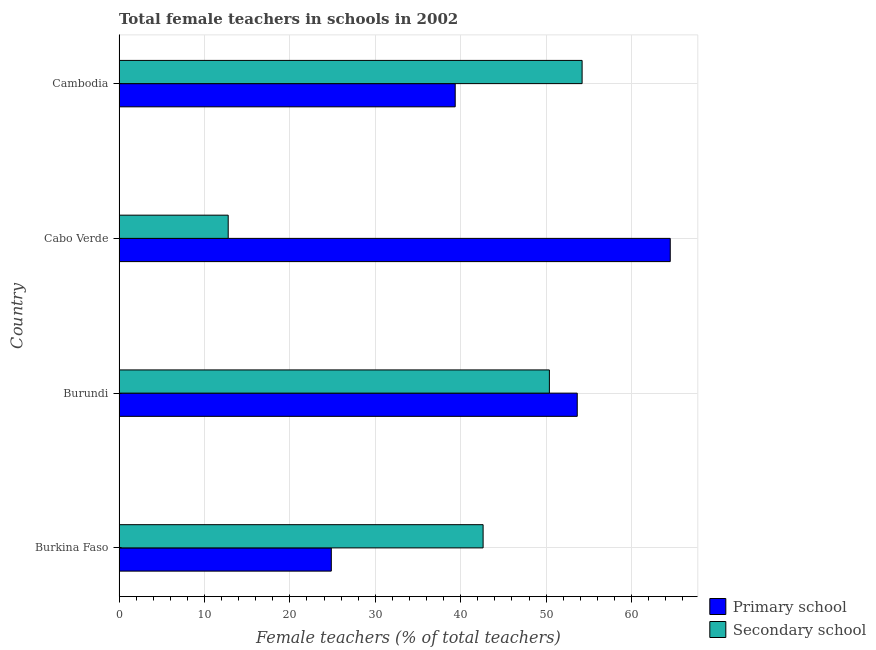How many different coloured bars are there?
Keep it short and to the point. 2. How many groups of bars are there?
Make the answer very short. 4. Are the number of bars per tick equal to the number of legend labels?
Provide a succinct answer. Yes. Are the number of bars on each tick of the Y-axis equal?
Provide a succinct answer. Yes. What is the label of the 3rd group of bars from the top?
Ensure brevity in your answer.  Burundi. What is the percentage of female teachers in primary schools in Cabo Verde?
Your response must be concise. 64.53. Across all countries, what is the maximum percentage of female teachers in primary schools?
Your answer should be compact. 64.53. Across all countries, what is the minimum percentage of female teachers in secondary schools?
Make the answer very short. 12.78. In which country was the percentage of female teachers in secondary schools maximum?
Keep it short and to the point. Cambodia. In which country was the percentage of female teachers in primary schools minimum?
Your response must be concise. Burkina Faso. What is the total percentage of female teachers in primary schools in the graph?
Your answer should be compact. 182.38. What is the difference between the percentage of female teachers in primary schools in Burkina Faso and that in Burundi?
Keep it short and to the point. -28.79. What is the difference between the percentage of female teachers in primary schools in Burundi and the percentage of female teachers in secondary schools in Burkina Faso?
Your response must be concise. 11.02. What is the average percentage of female teachers in secondary schools per country?
Make the answer very short. 40. What is the difference between the percentage of female teachers in primary schools and percentage of female teachers in secondary schools in Cabo Verde?
Make the answer very short. 51.75. In how many countries, is the percentage of female teachers in secondary schools greater than 62 %?
Offer a very short reply. 0. What is the ratio of the percentage of female teachers in primary schools in Burkina Faso to that in Cambodia?
Offer a terse response. 0.63. Is the percentage of female teachers in primary schools in Burkina Faso less than that in Cambodia?
Ensure brevity in your answer.  Yes. Is the difference between the percentage of female teachers in primary schools in Burkina Faso and Cambodia greater than the difference between the percentage of female teachers in secondary schools in Burkina Faso and Cambodia?
Give a very brief answer. No. What is the difference between the highest and the second highest percentage of female teachers in secondary schools?
Give a very brief answer. 3.83. What is the difference between the highest and the lowest percentage of female teachers in primary schools?
Your answer should be very brief. 39.68. What does the 1st bar from the top in Cambodia represents?
Your answer should be very brief. Secondary school. What does the 1st bar from the bottom in Burundi represents?
Keep it short and to the point. Primary school. How many bars are there?
Your answer should be compact. 8. Are all the bars in the graph horizontal?
Make the answer very short. Yes. How many legend labels are there?
Ensure brevity in your answer.  2. What is the title of the graph?
Your answer should be very brief. Total female teachers in schools in 2002. What is the label or title of the X-axis?
Provide a succinct answer. Female teachers (% of total teachers). What is the Female teachers (% of total teachers) of Primary school in Burkina Faso?
Your answer should be compact. 24.85. What is the Female teachers (% of total teachers) of Secondary school in Burkina Faso?
Give a very brief answer. 42.62. What is the Female teachers (% of total teachers) in Primary school in Burundi?
Give a very brief answer. 53.64. What is the Female teachers (% of total teachers) in Secondary school in Burundi?
Provide a short and direct response. 50.38. What is the Female teachers (% of total teachers) of Primary school in Cabo Verde?
Keep it short and to the point. 64.53. What is the Female teachers (% of total teachers) in Secondary school in Cabo Verde?
Your answer should be compact. 12.78. What is the Female teachers (% of total teachers) of Primary school in Cambodia?
Give a very brief answer. 39.36. What is the Female teachers (% of total teachers) in Secondary school in Cambodia?
Offer a terse response. 54.21. Across all countries, what is the maximum Female teachers (% of total teachers) of Primary school?
Your response must be concise. 64.53. Across all countries, what is the maximum Female teachers (% of total teachers) of Secondary school?
Make the answer very short. 54.21. Across all countries, what is the minimum Female teachers (% of total teachers) of Primary school?
Make the answer very short. 24.85. Across all countries, what is the minimum Female teachers (% of total teachers) of Secondary school?
Keep it short and to the point. 12.78. What is the total Female teachers (% of total teachers) of Primary school in the graph?
Offer a terse response. 182.38. What is the total Female teachers (% of total teachers) of Secondary school in the graph?
Your answer should be very brief. 159.99. What is the difference between the Female teachers (% of total teachers) in Primary school in Burkina Faso and that in Burundi?
Keep it short and to the point. -28.79. What is the difference between the Female teachers (% of total teachers) of Secondary school in Burkina Faso and that in Burundi?
Offer a terse response. -7.76. What is the difference between the Female teachers (% of total teachers) in Primary school in Burkina Faso and that in Cabo Verde?
Your answer should be compact. -39.68. What is the difference between the Female teachers (% of total teachers) of Secondary school in Burkina Faso and that in Cabo Verde?
Offer a very short reply. 29.84. What is the difference between the Female teachers (% of total teachers) in Primary school in Burkina Faso and that in Cambodia?
Your answer should be compact. -14.51. What is the difference between the Female teachers (% of total teachers) of Secondary school in Burkina Faso and that in Cambodia?
Make the answer very short. -11.59. What is the difference between the Female teachers (% of total teachers) of Primary school in Burundi and that in Cabo Verde?
Ensure brevity in your answer.  -10.89. What is the difference between the Female teachers (% of total teachers) in Secondary school in Burundi and that in Cabo Verde?
Give a very brief answer. 37.6. What is the difference between the Female teachers (% of total teachers) of Primary school in Burundi and that in Cambodia?
Keep it short and to the point. 14.29. What is the difference between the Female teachers (% of total teachers) in Secondary school in Burundi and that in Cambodia?
Your response must be concise. -3.83. What is the difference between the Female teachers (% of total teachers) in Primary school in Cabo Verde and that in Cambodia?
Your response must be concise. 25.18. What is the difference between the Female teachers (% of total teachers) in Secondary school in Cabo Verde and that in Cambodia?
Keep it short and to the point. -41.43. What is the difference between the Female teachers (% of total teachers) of Primary school in Burkina Faso and the Female teachers (% of total teachers) of Secondary school in Burundi?
Your answer should be very brief. -25.53. What is the difference between the Female teachers (% of total teachers) in Primary school in Burkina Faso and the Female teachers (% of total teachers) in Secondary school in Cabo Verde?
Your response must be concise. 12.07. What is the difference between the Female teachers (% of total teachers) in Primary school in Burkina Faso and the Female teachers (% of total teachers) in Secondary school in Cambodia?
Your answer should be very brief. -29.36. What is the difference between the Female teachers (% of total teachers) in Primary school in Burundi and the Female teachers (% of total teachers) in Secondary school in Cabo Verde?
Keep it short and to the point. 40.86. What is the difference between the Female teachers (% of total teachers) in Primary school in Burundi and the Female teachers (% of total teachers) in Secondary school in Cambodia?
Make the answer very short. -0.57. What is the difference between the Female teachers (% of total teachers) in Primary school in Cabo Verde and the Female teachers (% of total teachers) in Secondary school in Cambodia?
Keep it short and to the point. 10.32. What is the average Female teachers (% of total teachers) in Primary school per country?
Your answer should be very brief. 45.59. What is the average Female teachers (% of total teachers) of Secondary school per country?
Keep it short and to the point. 40. What is the difference between the Female teachers (% of total teachers) of Primary school and Female teachers (% of total teachers) of Secondary school in Burkina Faso?
Keep it short and to the point. -17.77. What is the difference between the Female teachers (% of total teachers) in Primary school and Female teachers (% of total teachers) in Secondary school in Burundi?
Make the answer very short. 3.26. What is the difference between the Female teachers (% of total teachers) in Primary school and Female teachers (% of total teachers) in Secondary school in Cabo Verde?
Your answer should be very brief. 51.75. What is the difference between the Female teachers (% of total teachers) in Primary school and Female teachers (% of total teachers) in Secondary school in Cambodia?
Keep it short and to the point. -14.86. What is the ratio of the Female teachers (% of total teachers) of Primary school in Burkina Faso to that in Burundi?
Your answer should be compact. 0.46. What is the ratio of the Female teachers (% of total teachers) of Secondary school in Burkina Faso to that in Burundi?
Offer a very short reply. 0.85. What is the ratio of the Female teachers (% of total teachers) in Primary school in Burkina Faso to that in Cabo Verde?
Keep it short and to the point. 0.39. What is the ratio of the Female teachers (% of total teachers) in Secondary school in Burkina Faso to that in Cabo Verde?
Provide a succinct answer. 3.34. What is the ratio of the Female teachers (% of total teachers) of Primary school in Burkina Faso to that in Cambodia?
Offer a very short reply. 0.63. What is the ratio of the Female teachers (% of total teachers) of Secondary school in Burkina Faso to that in Cambodia?
Offer a very short reply. 0.79. What is the ratio of the Female teachers (% of total teachers) of Primary school in Burundi to that in Cabo Verde?
Offer a very short reply. 0.83. What is the ratio of the Female teachers (% of total teachers) in Secondary school in Burundi to that in Cabo Verde?
Offer a terse response. 3.94. What is the ratio of the Female teachers (% of total teachers) of Primary school in Burundi to that in Cambodia?
Offer a very short reply. 1.36. What is the ratio of the Female teachers (% of total teachers) in Secondary school in Burundi to that in Cambodia?
Provide a succinct answer. 0.93. What is the ratio of the Female teachers (% of total teachers) of Primary school in Cabo Verde to that in Cambodia?
Your response must be concise. 1.64. What is the ratio of the Female teachers (% of total teachers) of Secondary school in Cabo Verde to that in Cambodia?
Provide a short and direct response. 0.24. What is the difference between the highest and the second highest Female teachers (% of total teachers) of Primary school?
Provide a succinct answer. 10.89. What is the difference between the highest and the second highest Female teachers (% of total teachers) in Secondary school?
Make the answer very short. 3.83. What is the difference between the highest and the lowest Female teachers (% of total teachers) in Primary school?
Make the answer very short. 39.68. What is the difference between the highest and the lowest Female teachers (% of total teachers) of Secondary school?
Provide a short and direct response. 41.43. 